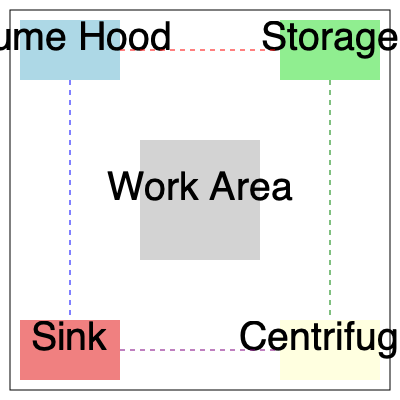In the given laboratory layout, which arrangement of equipment maximizes workflow efficiency while maintaining safety standards? Consider the following constraints:
1. The fume hood must be near an exterior wall for ventilation.
2. The storage area should be easily accessible but away from water sources.
3. The sink and centrifuge should be on opposite sides of the room.
4. The central work area should have clear paths to all other stations.

Identify the optimal flow pattern that connects all stations while minimizing cross-traffic and potential hazards. To determine the optimal flow pattern, we need to analyze the layout and constraints:

1. The fume hood is correctly placed near an exterior wall (top of the diagram).
2. The storage area is positioned away from the sink, meeting the requirement.
3. The sink and centrifuge are on opposite corners, satisfying the third constraint.
4. The central work area has clear access to all stations.

Now, let's establish the most efficient workflow:

1. Start at the storage area to retrieve materials.
2. Move to the fume hood for any chemical preparations or reactions requiring ventilation.
3. Proceed to the central work area for main experimental procedures.
4. Use the centrifuge when needed.
5. Finally, clean up at the sink.

This flow minimizes cross-traffic and potential hazards by:
- Keeping the path from storage to fume hood (red dashed line) away from the central work area.
- Establishing a clear route from fume hood to work area to centrifuge (blue dashed line).
- Creating a separate path from work area to sink (green dashed line).
- Allowing a direct route from centrifuge to sink for cleaning (purple dashed line).

The circular flow (clockwise or counterclockwise) around the central work area allows for easy access to all stations while maintaining a safe distance between potentially hazardous areas (e.g., fume hood and sink).
Answer: Clockwise flow: Storage → Fume Hood → Work Area → Centrifuge → Sink 